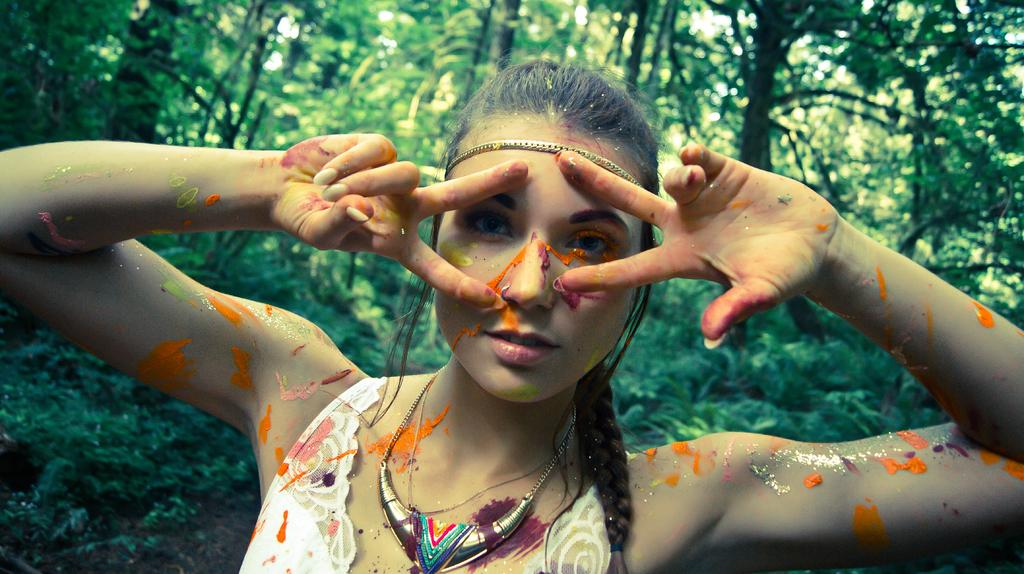Who is present in the image? There is a woman in the image. What can be seen in the background of the image? There are trees in the background of the image. What color is the cloud in the woman's eye in the image? There is no cloud or eye mentioned in the image; it only features a woman and trees in the background. 